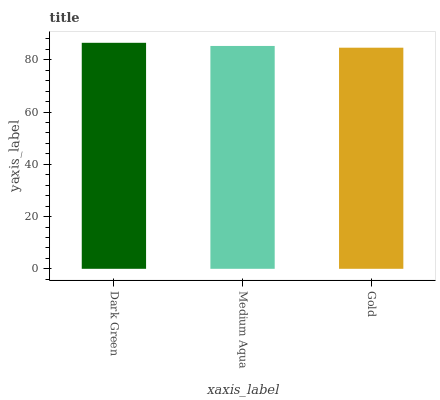Is Gold the minimum?
Answer yes or no. Yes. Is Dark Green the maximum?
Answer yes or no. Yes. Is Medium Aqua the minimum?
Answer yes or no. No. Is Medium Aqua the maximum?
Answer yes or no. No. Is Dark Green greater than Medium Aqua?
Answer yes or no. Yes. Is Medium Aqua less than Dark Green?
Answer yes or no. Yes. Is Medium Aqua greater than Dark Green?
Answer yes or no. No. Is Dark Green less than Medium Aqua?
Answer yes or no. No. Is Medium Aqua the high median?
Answer yes or no. Yes. Is Medium Aqua the low median?
Answer yes or no. Yes. Is Dark Green the high median?
Answer yes or no. No. Is Dark Green the low median?
Answer yes or no. No. 